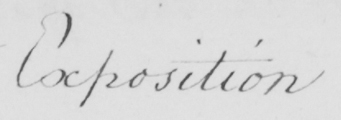Can you tell me what this handwritten text says? Exposition 